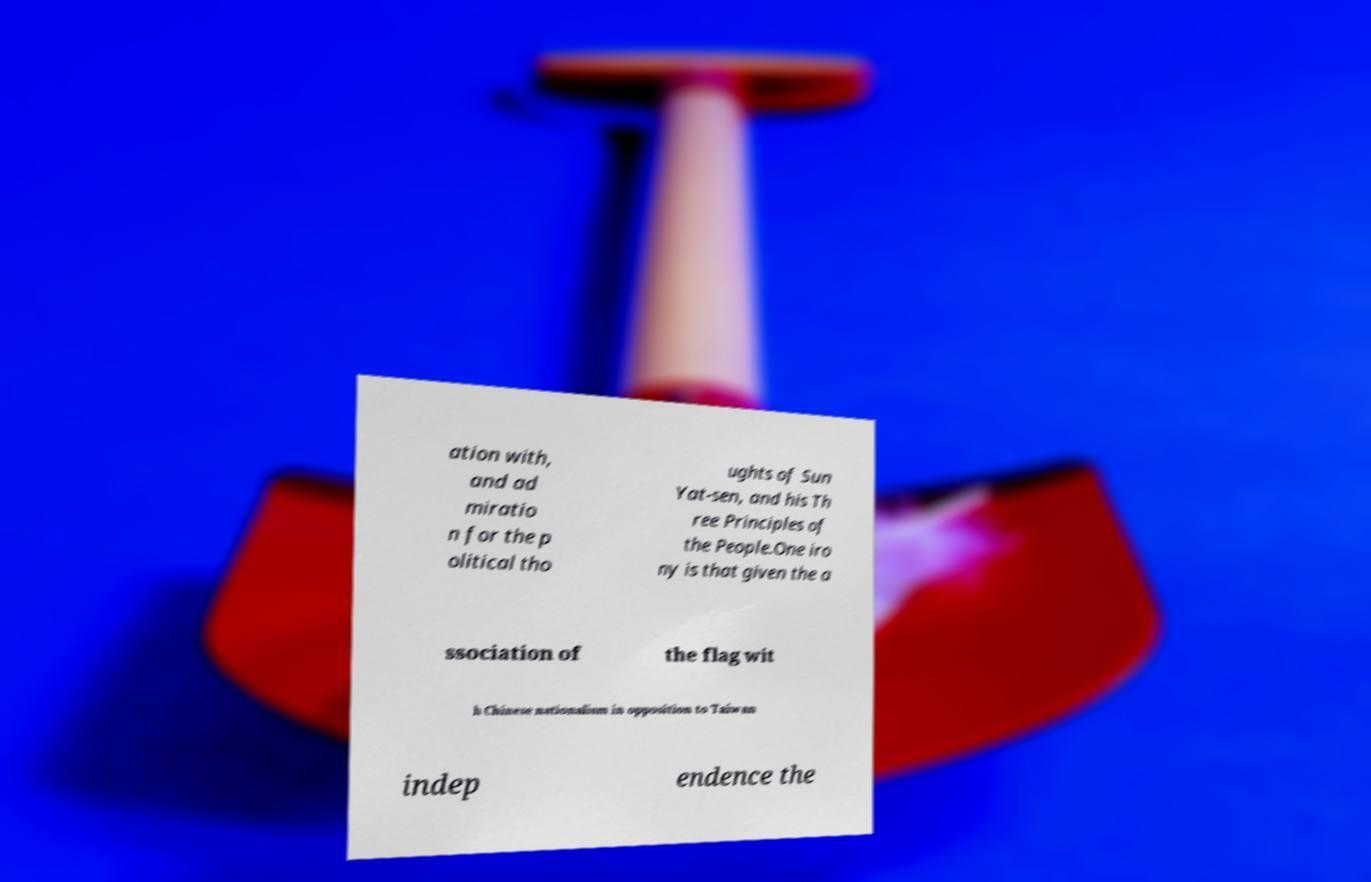Could you assist in decoding the text presented in this image and type it out clearly? ation with, and ad miratio n for the p olitical tho ughts of Sun Yat-sen, and his Th ree Principles of the People.One iro ny is that given the a ssociation of the flag wit h Chinese nationalism in opposition to Taiwan indep endence the 